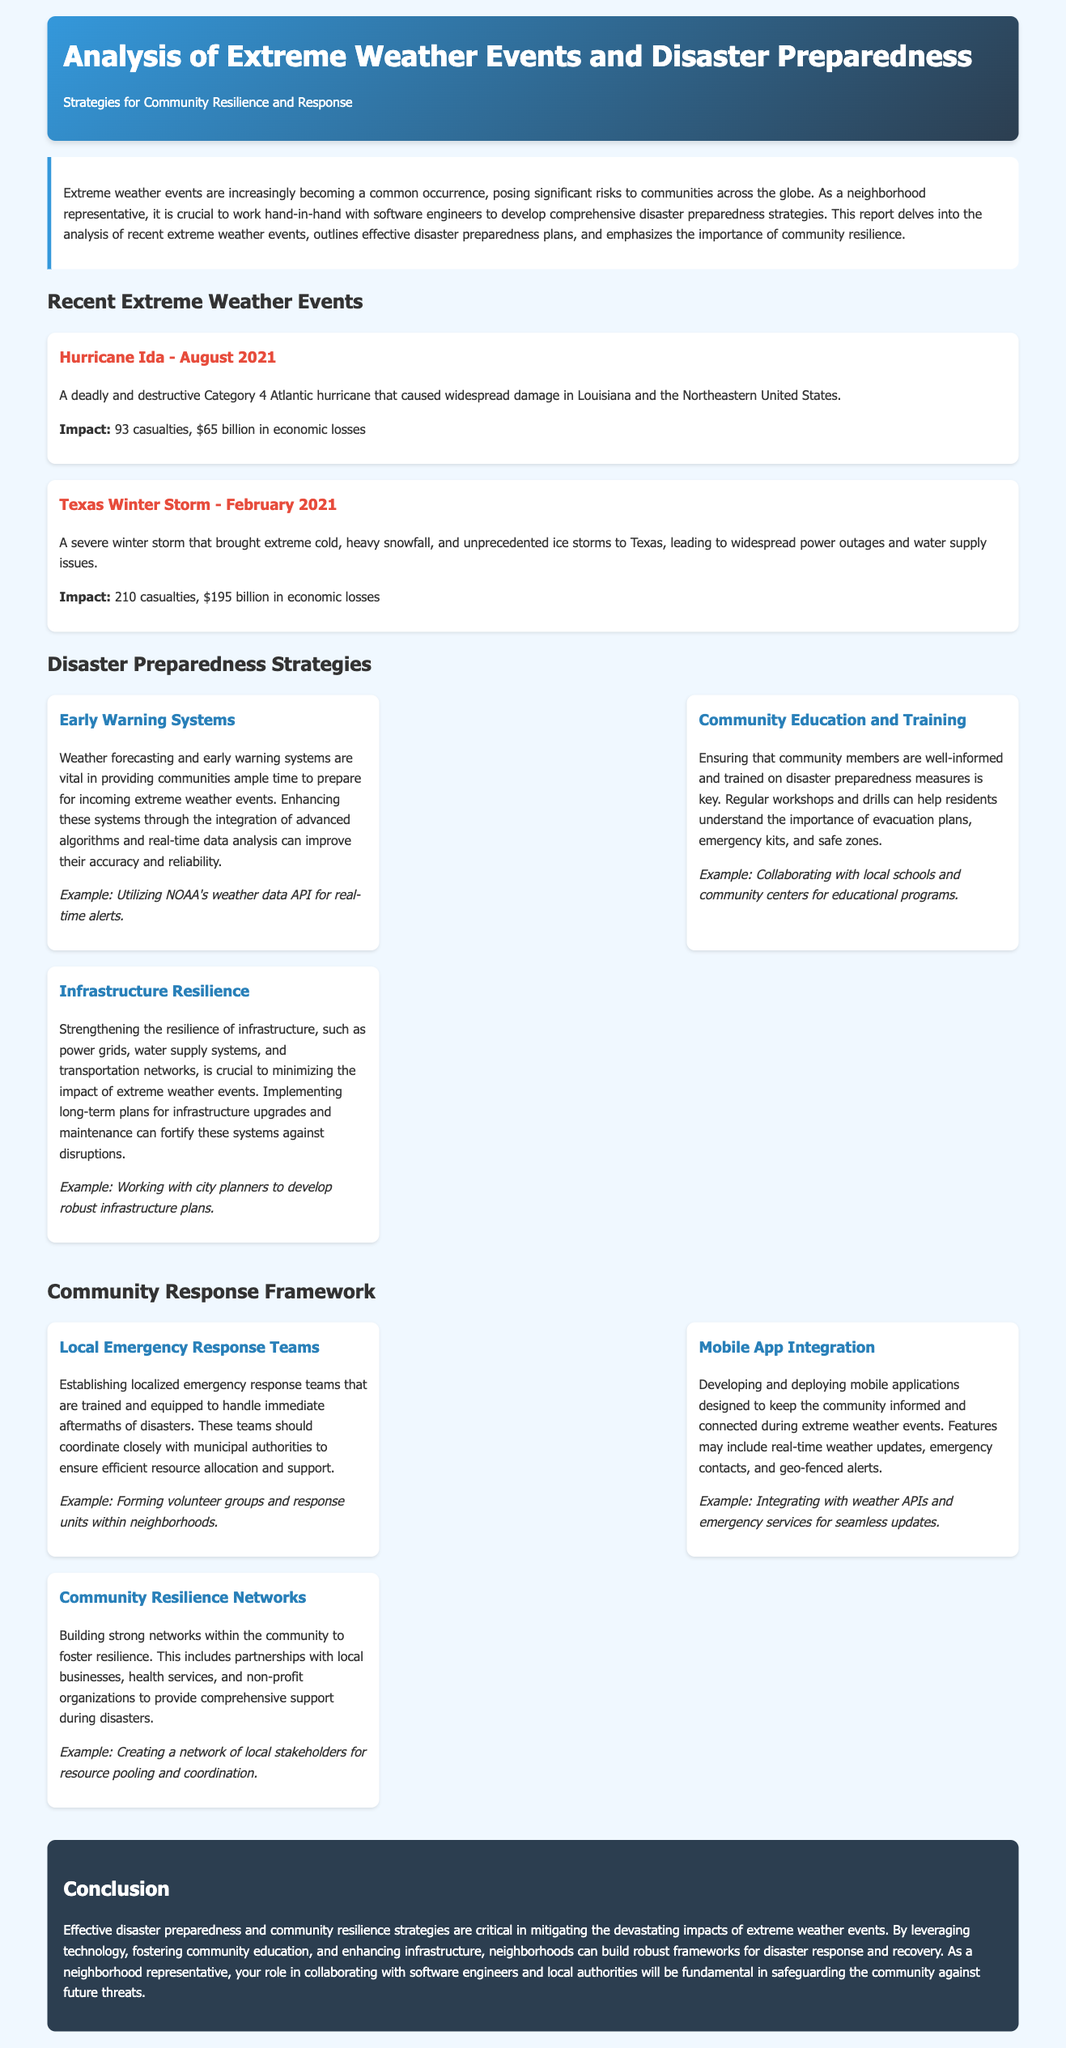What is the title of the document? The title of the document is highlighted at the top of the report as a main heading.
Answer: Analysis of Extreme Weather Events and Disaster Preparedness What hurricane is mentioned in the report? The report provides specific examples of recent extreme weather events, listing notable ones.
Answer: Hurricane Ida When did the Texas Winter Storm occur? The specific date of the Texas Winter Storm is mentioned in the event card section of the report.
Answer: February 2021 How many casualties were reported for the Texas Winter Storm? The number of casualties for the Texas Winter Storm is provided under its impact description.
Answer: 210 What is one strategy for disaster preparedness mentioned in the report? The report lists several strategies related to disaster preparedness.
Answer: Early Warning Systems What is one aspect of the community response framework? The document outlines components of the community response framework as part of its structure.
Answer: Local Emergency Response Teams What economic loss did Hurricane Ida cause? The economic losses resulting from Hurricane Ida are quantified in the impact section of the event card.
Answer: $65 billion What color scheme is used in the header of the document? The colors used in the header section can be identified from its design details within the document.
Answer: Gradient of blue and dark blue What does the conclusion emphasize for communities? The conclusion of the report summarizes key takeaways for community action, emphasizing a specific focus.
Answer: Community resilience strategies 